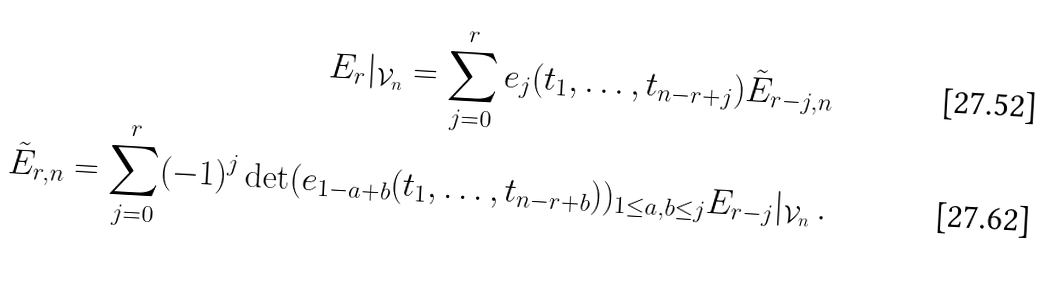Convert formula to latex. <formula><loc_0><loc_0><loc_500><loc_500>E _ { r } | _ { \mathcal { V } _ { n } } = \sum _ { j = 0 } ^ { r } e _ { j } ( t _ { 1 } , \dots , t _ { n - r + j } ) \tilde { E } _ { r - j , n } \\ \tilde { E } _ { r , n } = \sum _ { j = 0 } ^ { r } ( - 1 ) ^ { j } \det ( e _ { 1 - a + b } ( t _ { 1 } , \dots , t _ { n - r + b } ) ) _ { 1 \leq a , b \leq j } E _ { r - j } | _ { \mathcal { V } _ { n } } \, .</formula> 